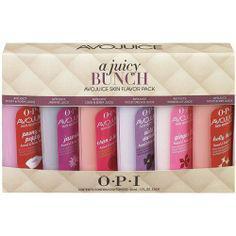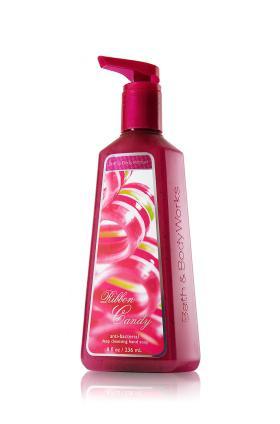The first image is the image on the left, the second image is the image on the right. Examine the images to the left and right. Is the description "At least one of the products is standing alone." accurate? Answer yes or no. Yes. The first image is the image on the left, the second image is the image on the right. Examine the images to the left and right. Is the description "At least one image features a single pump-top product." accurate? Answer yes or no. Yes. 